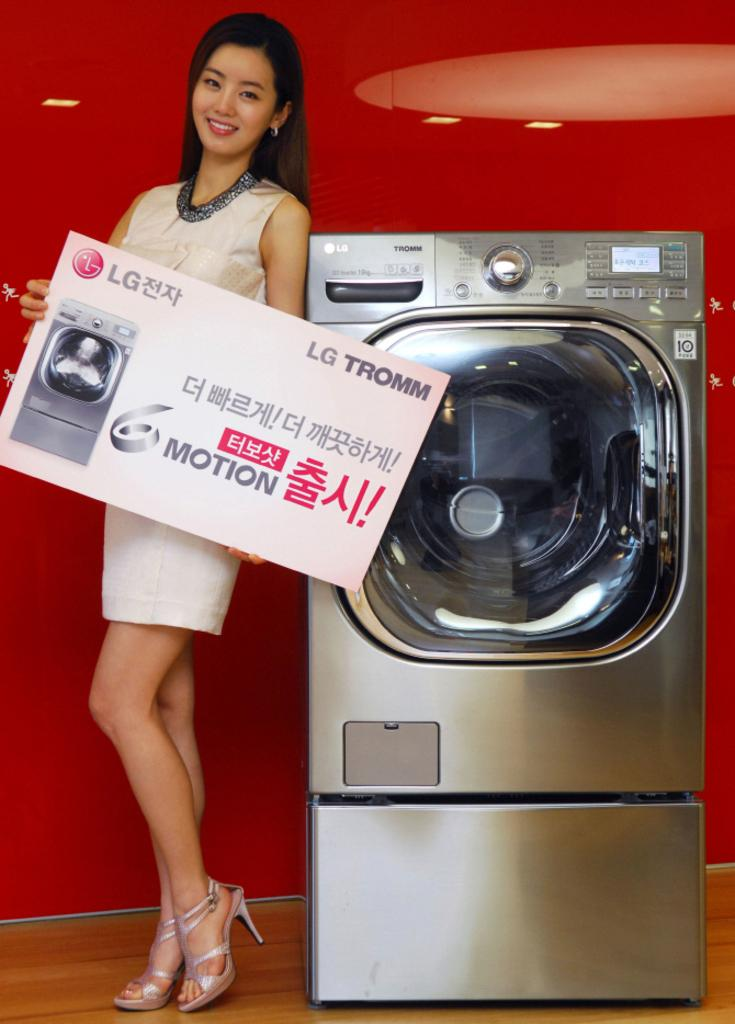<image>
Create a compact narrative representing the image presented. A picture of a LG Tromm washing machine. The background is red and there is a model on the picture holding a huge business card. 